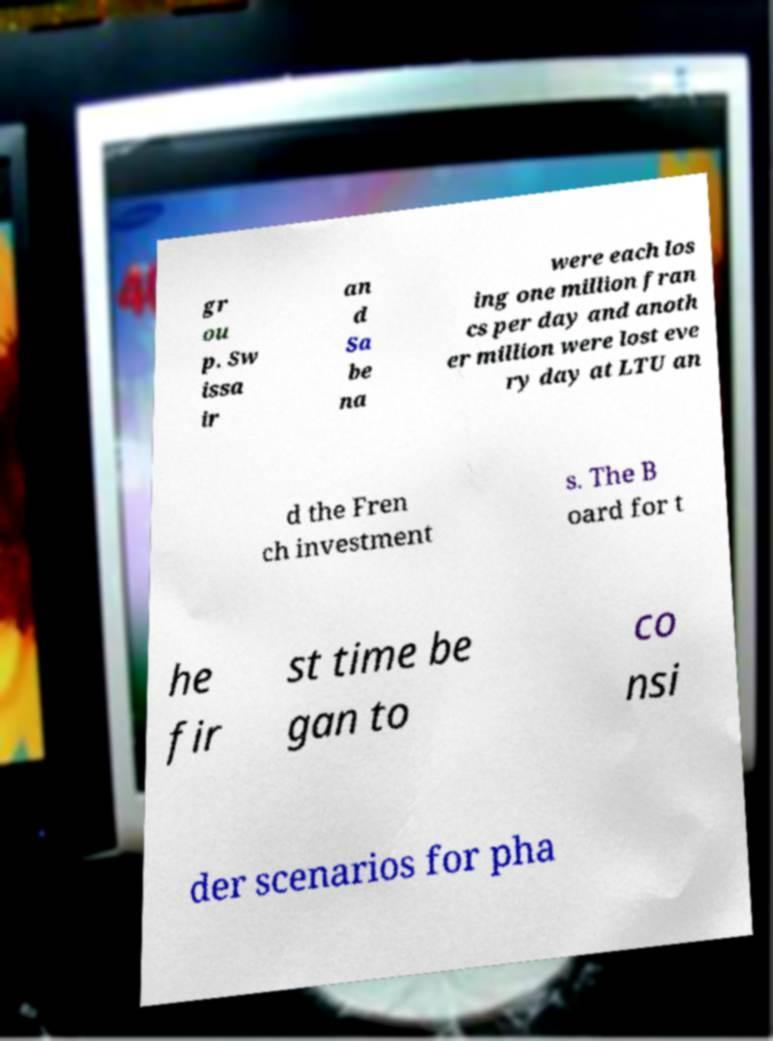There's text embedded in this image that I need extracted. Can you transcribe it verbatim? gr ou p. Sw issa ir an d Sa be na were each los ing one million fran cs per day and anoth er million were lost eve ry day at LTU an d the Fren ch investment s. The B oard for t he fir st time be gan to co nsi der scenarios for pha 